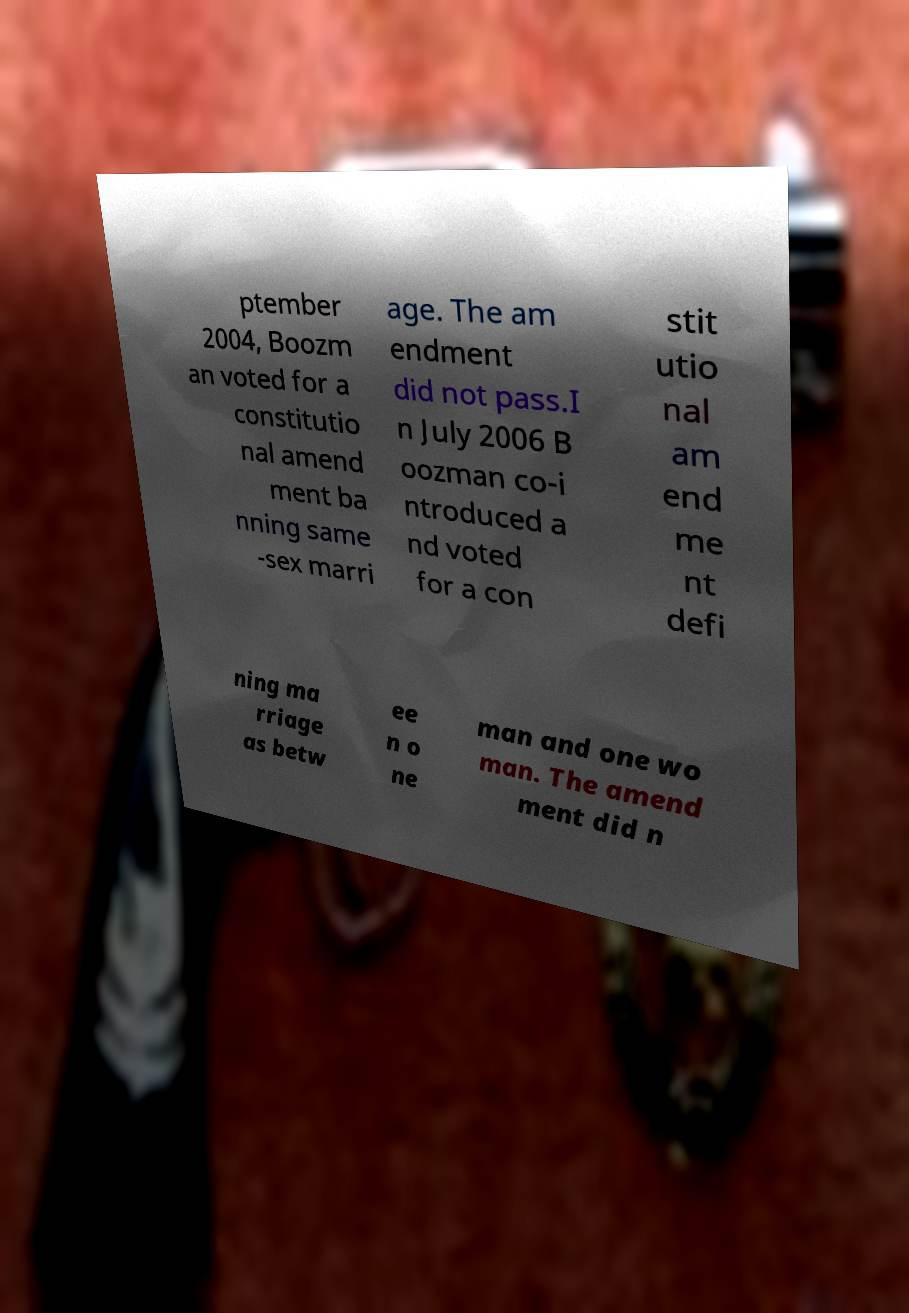What messages or text are displayed in this image? I need them in a readable, typed format. ptember 2004, Boozm an voted for a constitutio nal amend ment ba nning same -sex marri age. The am endment did not pass.I n July 2006 B oozman co-i ntroduced a nd voted for a con stit utio nal am end me nt defi ning ma rriage as betw ee n o ne man and one wo man. The amend ment did n 